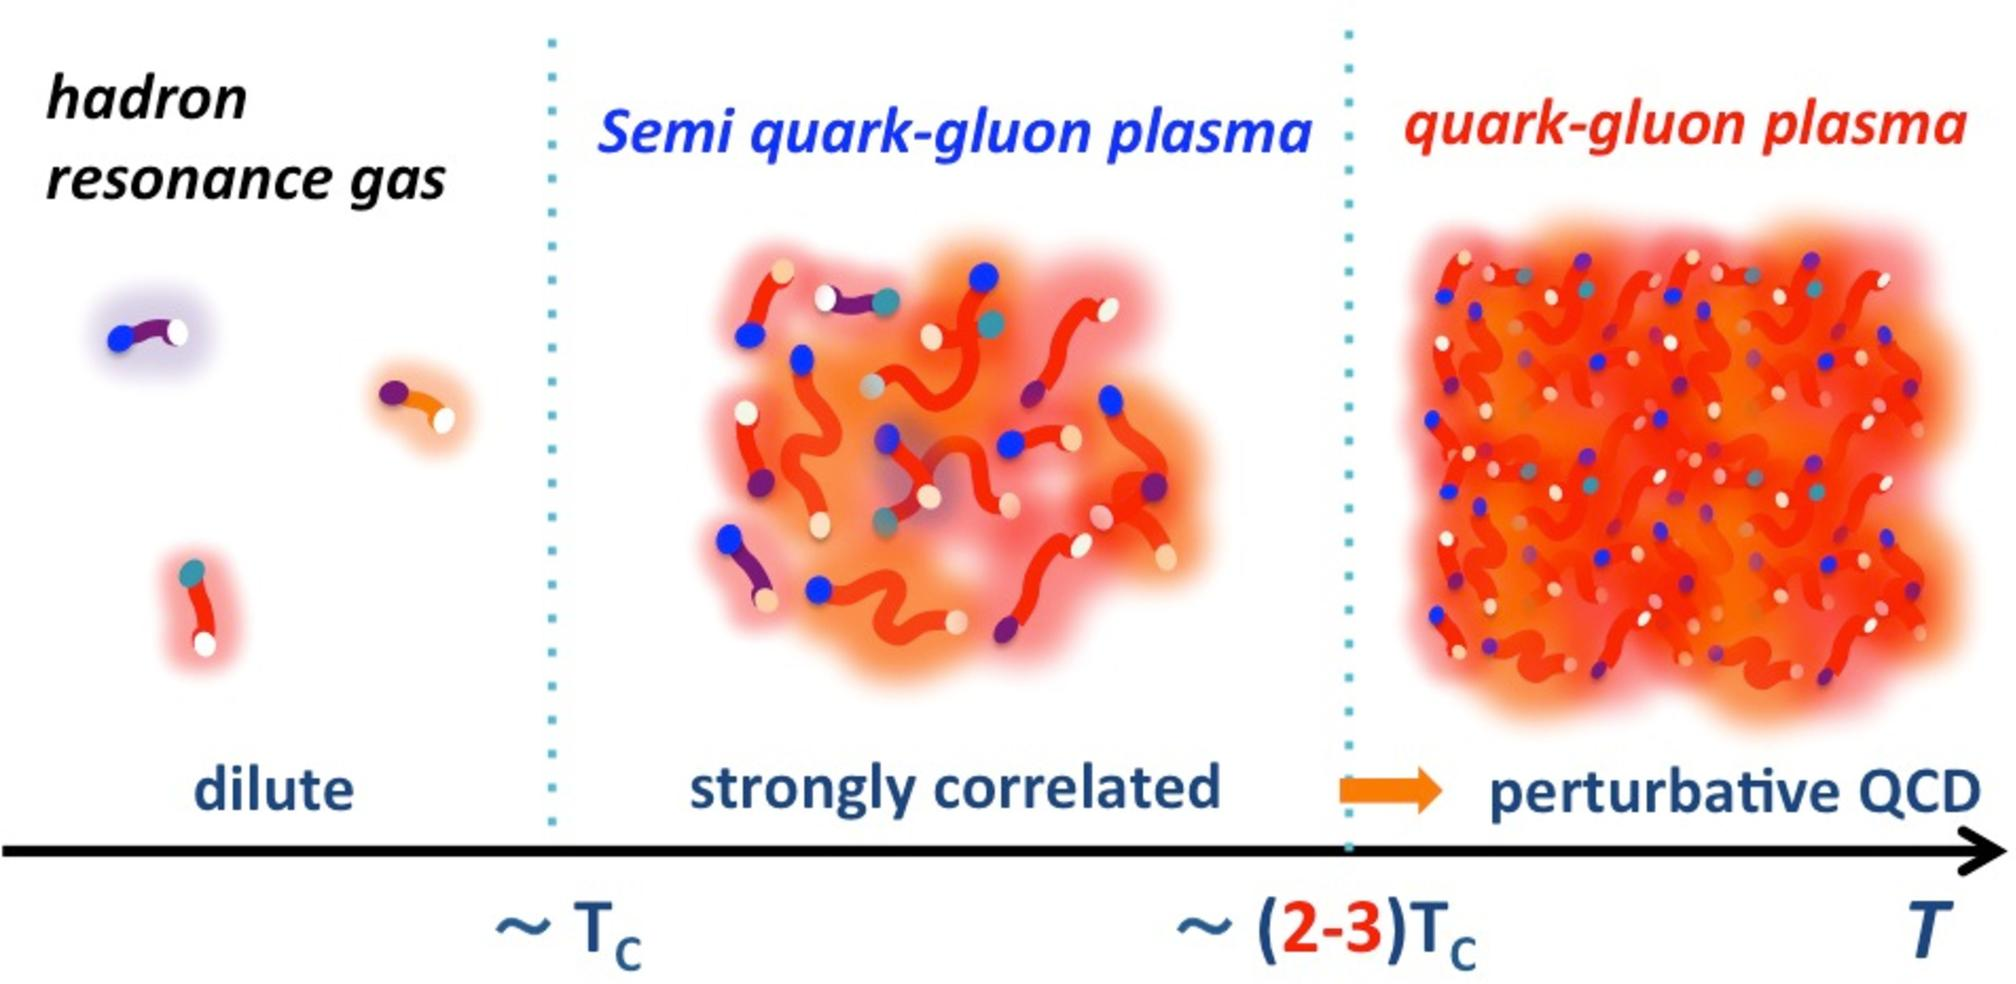What property of the quark-gluon plasma can be inferred from the figure as the temperature increases? A) The color charge of quarks becomes confined. B) The correlation between quarks and gluons decreases. C) The density of the plasma decreases. D) The plasma transitions into a hadron resonance gas. Upon carefully examining the image, it becomes evident that as the temperature progresses from T_c to higher temperatures (T), there is a distinct transformation in the state of matter, moving from a semi quark-gluon plasma to a fully perturbative quark-gluon plasma. This change entails a loss of the tight correlation once observed between quarks and gluons. In this perturbative Quantum Chromodynamics (QCD) state, the interaction dynamics between quarks and gluons are less confined, illustrating a significant reduction in their direct interactions. Therefore, the most accurate answer is B, depicting the decrease in correlation between quarks and gluons. 